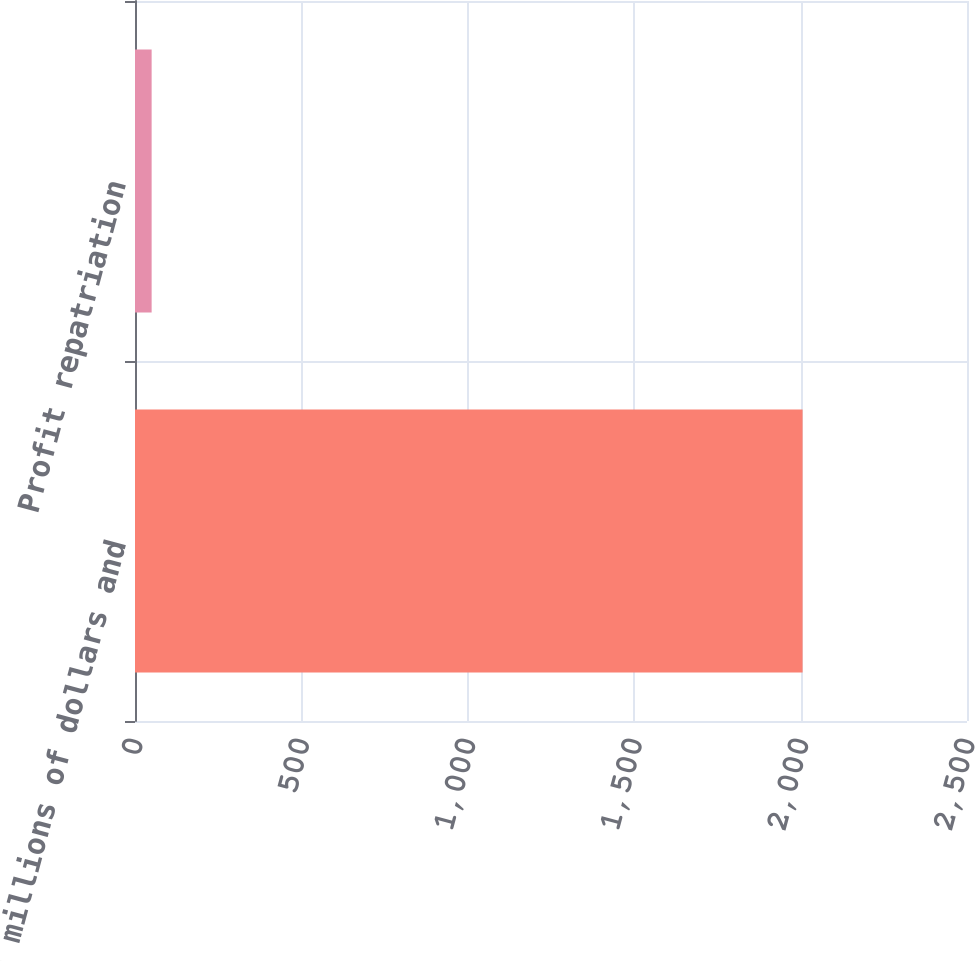Convert chart to OTSL. <chart><loc_0><loc_0><loc_500><loc_500><bar_chart><fcel>(In millions of dollars and<fcel>Profit repatriation<nl><fcel>2006<fcel>50<nl></chart> 